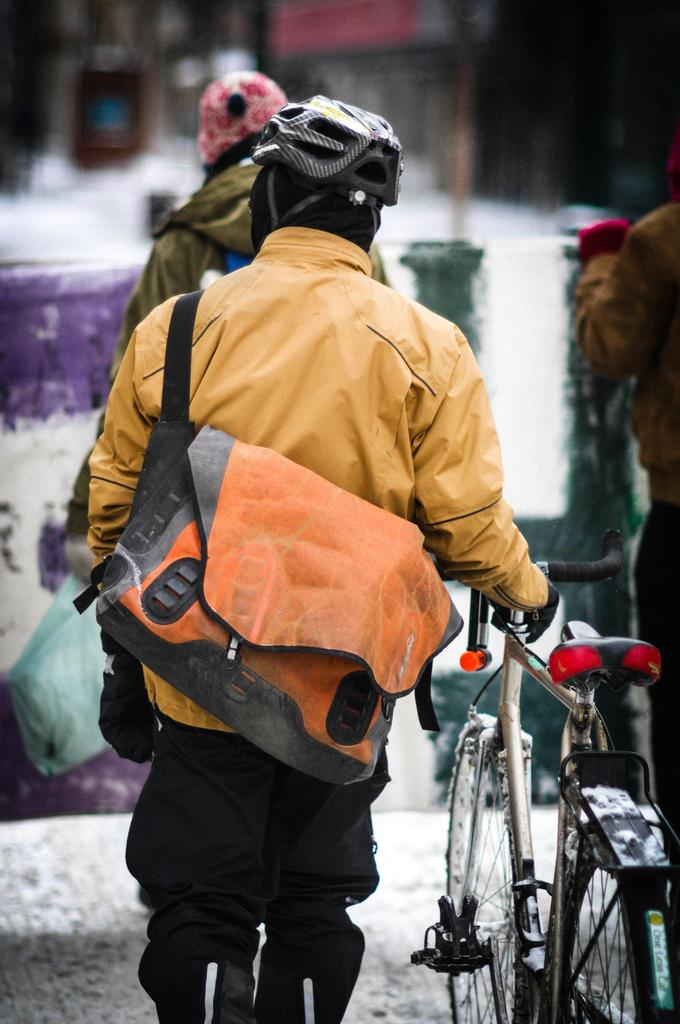How many people are in the image? There is a group of people in the image. Can you describe the man in the middle of the image? The man in the middle of the image is wearing a bag and a helmet. What is the man holding in the image? The man is holding a bicycle. What type of plantation can be seen in the background of the image? There is no plantation visible in the image. How much money is the man holding in the image? The man is not holding any money in the image; he is holding a bicycle. 